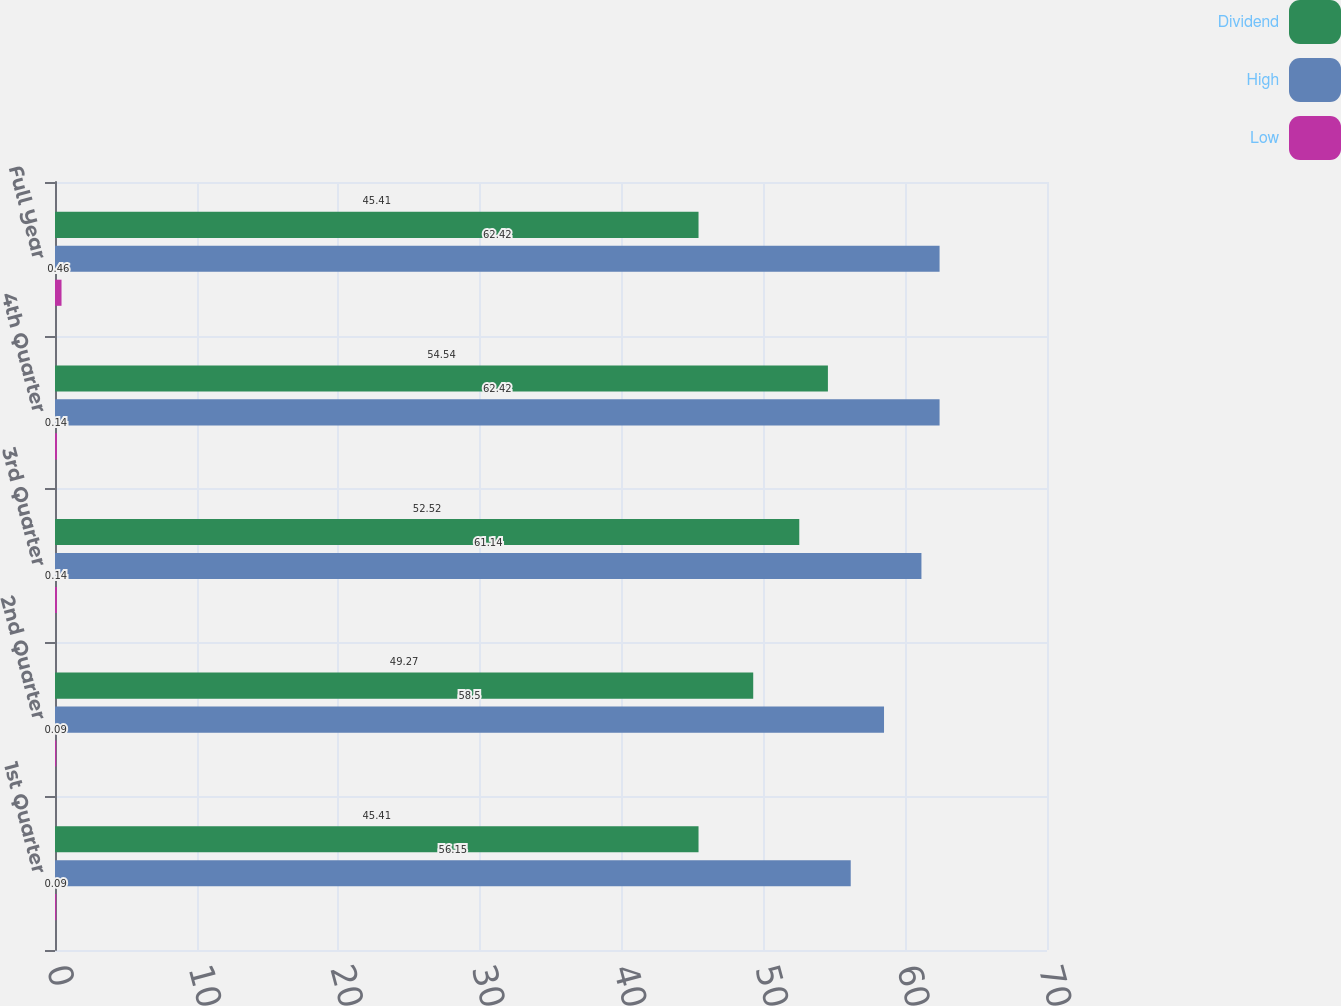Convert chart. <chart><loc_0><loc_0><loc_500><loc_500><stacked_bar_chart><ecel><fcel>1st Quarter<fcel>2nd Quarter<fcel>3rd Quarter<fcel>4th Quarter<fcel>Full Year<nl><fcel>Dividend<fcel>45.41<fcel>49.27<fcel>52.52<fcel>54.54<fcel>45.41<nl><fcel>High<fcel>56.15<fcel>58.5<fcel>61.14<fcel>62.42<fcel>62.42<nl><fcel>Low<fcel>0.09<fcel>0.09<fcel>0.14<fcel>0.14<fcel>0.46<nl></chart> 